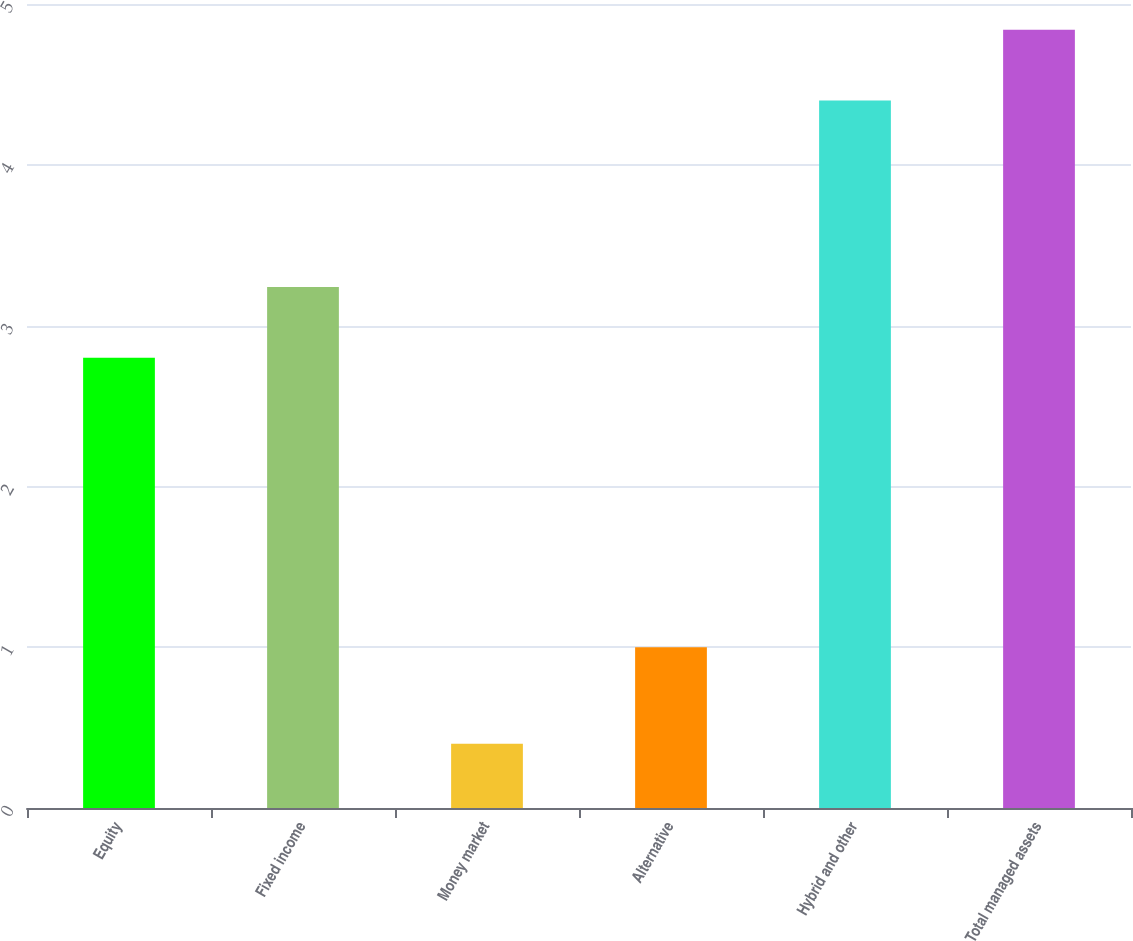Convert chart. <chart><loc_0><loc_0><loc_500><loc_500><bar_chart><fcel>Equity<fcel>Fixed income<fcel>Money market<fcel>Alternative<fcel>Hybrid and other<fcel>Total managed assets<nl><fcel>2.8<fcel>3.24<fcel>0.4<fcel>1<fcel>4.4<fcel>4.84<nl></chart> 